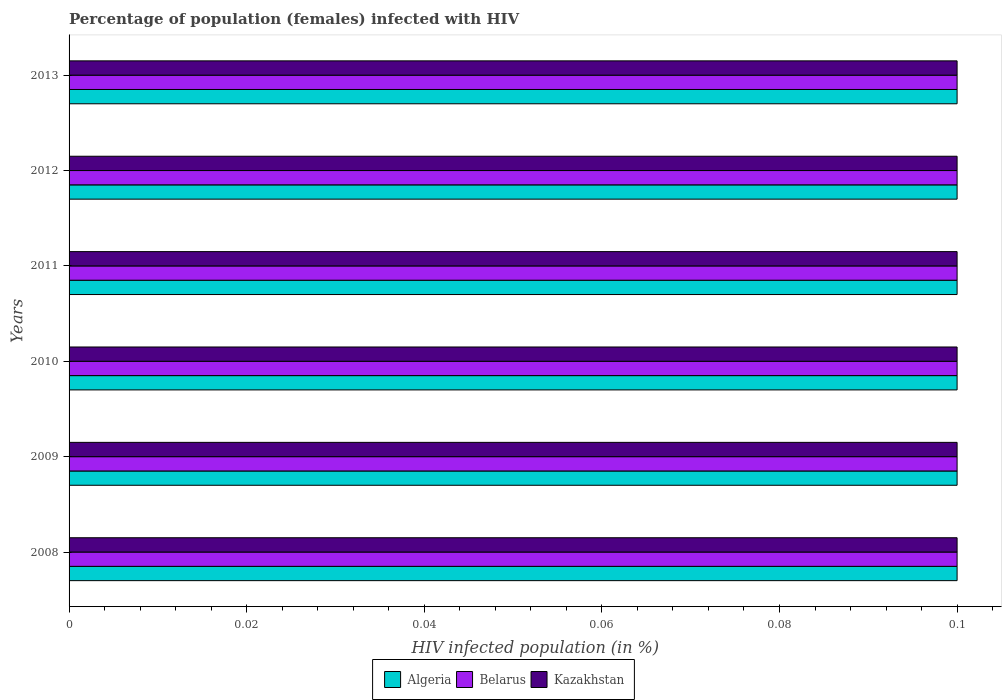How many bars are there on the 5th tick from the top?
Your response must be concise. 3. How many bars are there on the 5th tick from the bottom?
Give a very brief answer. 3. In how many cases, is the number of bars for a given year not equal to the number of legend labels?
Offer a very short reply. 0. In which year was the percentage of HIV infected female population in Belarus maximum?
Make the answer very short. 2008. In which year was the percentage of HIV infected female population in Algeria minimum?
Provide a succinct answer. 2008. What is the average percentage of HIV infected female population in Kazakhstan per year?
Offer a very short reply. 0.1. In how many years, is the percentage of HIV infected female population in Belarus greater than 0.012 %?
Provide a short and direct response. 6. Is the percentage of HIV infected female population in Belarus in 2009 less than that in 2010?
Your answer should be very brief. No. In how many years, is the percentage of HIV infected female population in Kazakhstan greater than the average percentage of HIV infected female population in Kazakhstan taken over all years?
Ensure brevity in your answer.  6. What does the 2nd bar from the top in 2011 represents?
Provide a succinct answer. Belarus. What does the 2nd bar from the bottom in 2011 represents?
Your answer should be compact. Belarus. How many bars are there?
Make the answer very short. 18. Are the values on the major ticks of X-axis written in scientific E-notation?
Give a very brief answer. No. Does the graph contain any zero values?
Offer a very short reply. No. Does the graph contain grids?
Keep it short and to the point. No. Where does the legend appear in the graph?
Ensure brevity in your answer.  Bottom center. How many legend labels are there?
Your answer should be compact. 3. How are the legend labels stacked?
Give a very brief answer. Horizontal. What is the title of the graph?
Your response must be concise. Percentage of population (females) infected with HIV. Does "San Marino" appear as one of the legend labels in the graph?
Offer a terse response. No. What is the label or title of the X-axis?
Your answer should be compact. HIV infected population (in %). What is the HIV infected population (in %) of Algeria in 2008?
Provide a short and direct response. 0.1. What is the HIV infected population (in %) of Belarus in 2008?
Your response must be concise. 0.1. What is the HIV infected population (in %) of Kazakhstan in 2008?
Make the answer very short. 0.1. What is the HIV infected population (in %) in Belarus in 2009?
Your answer should be very brief. 0.1. What is the HIV infected population (in %) in Algeria in 2010?
Offer a very short reply. 0.1. What is the HIV infected population (in %) in Belarus in 2010?
Offer a very short reply. 0.1. What is the HIV infected population (in %) in Algeria in 2011?
Your response must be concise. 0.1. What is the HIV infected population (in %) in Belarus in 2011?
Ensure brevity in your answer.  0.1. What is the HIV infected population (in %) in Kazakhstan in 2011?
Give a very brief answer. 0.1. What is the HIV infected population (in %) of Belarus in 2012?
Ensure brevity in your answer.  0.1. What is the HIV infected population (in %) in Kazakhstan in 2012?
Ensure brevity in your answer.  0.1. What is the HIV infected population (in %) of Algeria in 2013?
Make the answer very short. 0.1. What is the HIV infected population (in %) in Belarus in 2013?
Keep it short and to the point. 0.1. What is the HIV infected population (in %) of Kazakhstan in 2013?
Your response must be concise. 0.1. Across all years, what is the maximum HIV infected population (in %) in Kazakhstan?
Your answer should be very brief. 0.1. Across all years, what is the minimum HIV infected population (in %) of Algeria?
Your response must be concise. 0.1. Across all years, what is the minimum HIV infected population (in %) in Belarus?
Provide a succinct answer. 0.1. What is the total HIV infected population (in %) in Algeria in the graph?
Offer a terse response. 0.6. What is the difference between the HIV infected population (in %) in Algeria in 2008 and that in 2009?
Provide a succinct answer. 0. What is the difference between the HIV infected population (in %) of Belarus in 2008 and that in 2009?
Provide a short and direct response. 0. What is the difference between the HIV infected population (in %) of Kazakhstan in 2008 and that in 2009?
Make the answer very short. 0. What is the difference between the HIV infected population (in %) of Algeria in 2008 and that in 2011?
Your response must be concise. 0. What is the difference between the HIV infected population (in %) in Belarus in 2008 and that in 2011?
Your response must be concise. 0. What is the difference between the HIV infected population (in %) in Kazakhstan in 2008 and that in 2011?
Offer a terse response. 0. What is the difference between the HIV infected population (in %) of Algeria in 2008 and that in 2012?
Make the answer very short. 0. What is the difference between the HIV infected population (in %) of Algeria in 2008 and that in 2013?
Provide a short and direct response. 0. What is the difference between the HIV infected population (in %) of Belarus in 2008 and that in 2013?
Provide a short and direct response. 0. What is the difference between the HIV infected population (in %) in Kazakhstan in 2008 and that in 2013?
Keep it short and to the point. 0. What is the difference between the HIV infected population (in %) in Algeria in 2009 and that in 2010?
Your response must be concise. 0. What is the difference between the HIV infected population (in %) in Belarus in 2009 and that in 2010?
Make the answer very short. 0. What is the difference between the HIV infected population (in %) of Kazakhstan in 2009 and that in 2010?
Keep it short and to the point. 0. What is the difference between the HIV infected population (in %) in Algeria in 2009 and that in 2011?
Keep it short and to the point. 0. What is the difference between the HIV infected population (in %) of Belarus in 2009 and that in 2011?
Offer a very short reply. 0. What is the difference between the HIV infected population (in %) in Kazakhstan in 2009 and that in 2011?
Your response must be concise. 0. What is the difference between the HIV infected population (in %) in Algeria in 2009 and that in 2012?
Provide a short and direct response. 0. What is the difference between the HIV infected population (in %) in Belarus in 2009 and that in 2012?
Your response must be concise. 0. What is the difference between the HIV infected population (in %) in Kazakhstan in 2009 and that in 2012?
Give a very brief answer. 0. What is the difference between the HIV infected population (in %) in Belarus in 2009 and that in 2013?
Make the answer very short. 0. What is the difference between the HIV infected population (in %) in Kazakhstan in 2010 and that in 2011?
Make the answer very short. 0. What is the difference between the HIV infected population (in %) in Algeria in 2010 and that in 2012?
Your response must be concise. 0. What is the difference between the HIV infected population (in %) of Belarus in 2010 and that in 2012?
Your answer should be very brief. 0. What is the difference between the HIV infected population (in %) of Belarus in 2010 and that in 2013?
Your answer should be compact. 0. What is the difference between the HIV infected population (in %) in Belarus in 2011 and that in 2012?
Your response must be concise. 0. What is the difference between the HIV infected population (in %) of Kazakhstan in 2011 and that in 2012?
Keep it short and to the point. 0. What is the difference between the HIV infected population (in %) of Kazakhstan in 2011 and that in 2013?
Offer a very short reply. 0. What is the difference between the HIV infected population (in %) of Algeria in 2008 and the HIV infected population (in %) of Belarus in 2009?
Provide a succinct answer. 0. What is the difference between the HIV infected population (in %) in Belarus in 2008 and the HIV infected population (in %) in Kazakhstan in 2009?
Your answer should be very brief. 0. What is the difference between the HIV infected population (in %) in Belarus in 2008 and the HIV infected population (in %) in Kazakhstan in 2010?
Keep it short and to the point. 0. What is the difference between the HIV infected population (in %) of Algeria in 2008 and the HIV infected population (in %) of Belarus in 2012?
Ensure brevity in your answer.  0. What is the difference between the HIV infected population (in %) in Algeria in 2008 and the HIV infected population (in %) in Kazakhstan in 2013?
Make the answer very short. 0. What is the difference between the HIV infected population (in %) of Belarus in 2008 and the HIV infected population (in %) of Kazakhstan in 2013?
Ensure brevity in your answer.  0. What is the difference between the HIV infected population (in %) of Algeria in 2009 and the HIV infected population (in %) of Belarus in 2011?
Offer a terse response. 0. What is the difference between the HIV infected population (in %) of Algeria in 2009 and the HIV infected population (in %) of Kazakhstan in 2012?
Provide a succinct answer. 0. What is the difference between the HIV infected population (in %) of Algeria in 2010 and the HIV infected population (in %) of Kazakhstan in 2011?
Your answer should be compact. 0. What is the difference between the HIV infected population (in %) in Belarus in 2010 and the HIV infected population (in %) in Kazakhstan in 2011?
Give a very brief answer. 0. What is the difference between the HIV infected population (in %) in Belarus in 2010 and the HIV infected population (in %) in Kazakhstan in 2012?
Make the answer very short. 0. What is the difference between the HIV infected population (in %) in Algeria in 2010 and the HIV infected population (in %) in Belarus in 2013?
Make the answer very short. 0. What is the difference between the HIV infected population (in %) of Algeria in 2010 and the HIV infected population (in %) of Kazakhstan in 2013?
Provide a short and direct response. 0. What is the difference between the HIV infected population (in %) in Belarus in 2010 and the HIV infected population (in %) in Kazakhstan in 2013?
Provide a succinct answer. 0. What is the difference between the HIV infected population (in %) of Algeria in 2011 and the HIV infected population (in %) of Kazakhstan in 2012?
Offer a terse response. 0. What is the difference between the HIV infected population (in %) of Belarus in 2011 and the HIV infected population (in %) of Kazakhstan in 2012?
Offer a very short reply. 0. What is the difference between the HIV infected population (in %) of Algeria in 2011 and the HIV infected population (in %) of Kazakhstan in 2013?
Your answer should be very brief. 0. What is the difference between the HIV infected population (in %) in Algeria in 2012 and the HIV infected population (in %) in Belarus in 2013?
Provide a succinct answer. 0. What is the difference between the HIV infected population (in %) of Belarus in 2012 and the HIV infected population (in %) of Kazakhstan in 2013?
Provide a short and direct response. 0. What is the average HIV infected population (in %) of Algeria per year?
Provide a succinct answer. 0.1. What is the average HIV infected population (in %) of Kazakhstan per year?
Your answer should be very brief. 0.1. In the year 2008, what is the difference between the HIV infected population (in %) in Algeria and HIV infected population (in %) in Kazakhstan?
Provide a short and direct response. 0. In the year 2008, what is the difference between the HIV infected population (in %) of Belarus and HIV infected population (in %) of Kazakhstan?
Your answer should be compact. 0. In the year 2009, what is the difference between the HIV infected population (in %) in Algeria and HIV infected population (in %) in Belarus?
Your response must be concise. 0. In the year 2010, what is the difference between the HIV infected population (in %) in Algeria and HIV infected population (in %) in Belarus?
Your answer should be very brief. 0. In the year 2011, what is the difference between the HIV infected population (in %) of Algeria and HIV infected population (in %) of Kazakhstan?
Ensure brevity in your answer.  0. In the year 2011, what is the difference between the HIV infected population (in %) in Belarus and HIV infected population (in %) in Kazakhstan?
Your answer should be compact. 0. In the year 2012, what is the difference between the HIV infected population (in %) in Algeria and HIV infected population (in %) in Kazakhstan?
Provide a succinct answer. 0. In the year 2013, what is the difference between the HIV infected population (in %) of Algeria and HIV infected population (in %) of Belarus?
Give a very brief answer. 0. In the year 2013, what is the difference between the HIV infected population (in %) in Algeria and HIV infected population (in %) in Kazakhstan?
Your answer should be very brief. 0. In the year 2013, what is the difference between the HIV infected population (in %) of Belarus and HIV infected population (in %) of Kazakhstan?
Provide a short and direct response. 0. What is the ratio of the HIV infected population (in %) of Algeria in 2008 to that in 2009?
Provide a succinct answer. 1. What is the ratio of the HIV infected population (in %) of Algeria in 2008 to that in 2010?
Give a very brief answer. 1. What is the ratio of the HIV infected population (in %) in Belarus in 2008 to that in 2010?
Your response must be concise. 1. What is the ratio of the HIV infected population (in %) of Kazakhstan in 2008 to that in 2010?
Provide a succinct answer. 1. What is the ratio of the HIV infected population (in %) in Belarus in 2008 to that in 2011?
Provide a short and direct response. 1. What is the ratio of the HIV infected population (in %) in Kazakhstan in 2008 to that in 2011?
Make the answer very short. 1. What is the ratio of the HIV infected population (in %) of Algeria in 2008 to that in 2012?
Keep it short and to the point. 1. What is the ratio of the HIV infected population (in %) of Kazakhstan in 2008 to that in 2012?
Make the answer very short. 1. What is the ratio of the HIV infected population (in %) of Belarus in 2008 to that in 2013?
Your answer should be compact. 1. What is the ratio of the HIV infected population (in %) of Kazakhstan in 2008 to that in 2013?
Give a very brief answer. 1. What is the ratio of the HIV infected population (in %) in Algeria in 2009 to that in 2010?
Offer a terse response. 1. What is the ratio of the HIV infected population (in %) of Kazakhstan in 2009 to that in 2010?
Give a very brief answer. 1. What is the ratio of the HIV infected population (in %) of Algeria in 2009 to that in 2011?
Provide a short and direct response. 1. What is the ratio of the HIV infected population (in %) in Belarus in 2009 to that in 2011?
Give a very brief answer. 1. What is the ratio of the HIV infected population (in %) of Kazakhstan in 2009 to that in 2011?
Give a very brief answer. 1. What is the ratio of the HIV infected population (in %) of Kazakhstan in 2009 to that in 2012?
Make the answer very short. 1. What is the ratio of the HIV infected population (in %) in Algeria in 2009 to that in 2013?
Your response must be concise. 1. What is the ratio of the HIV infected population (in %) of Belarus in 2010 to that in 2011?
Keep it short and to the point. 1. What is the ratio of the HIV infected population (in %) in Belarus in 2010 to that in 2012?
Your response must be concise. 1. What is the ratio of the HIV infected population (in %) in Kazakhstan in 2010 to that in 2012?
Provide a succinct answer. 1. What is the ratio of the HIV infected population (in %) of Algeria in 2010 to that in 2013?
Provide a succinct answer. 1. What is the ratio of the HIV infected population (in %) in Belarus in 2011 to that in 2013?
Ensure brevity in your answer.  1. What is the ratio of the HIV infected population (in %) in Belarus in 2012 to that in 2013?
Offer a terse response. 1. What is the difference between the highest and the second highest HIV infected population (in %) of Belarus?
Offer a very short reply. 0. What is the difference between the highest and the second highest HIV infected population (in %) in Kazakhstan?
Keep it short and to the point. 0. What is the difference between the highest and the lowest HIV infected population (in %) in Algeria?
Provide a short and direct response. 0. What is the difference between the highest and the lowest HIV infected population (in %) in Belarus?
Offer a terse response. 0. 